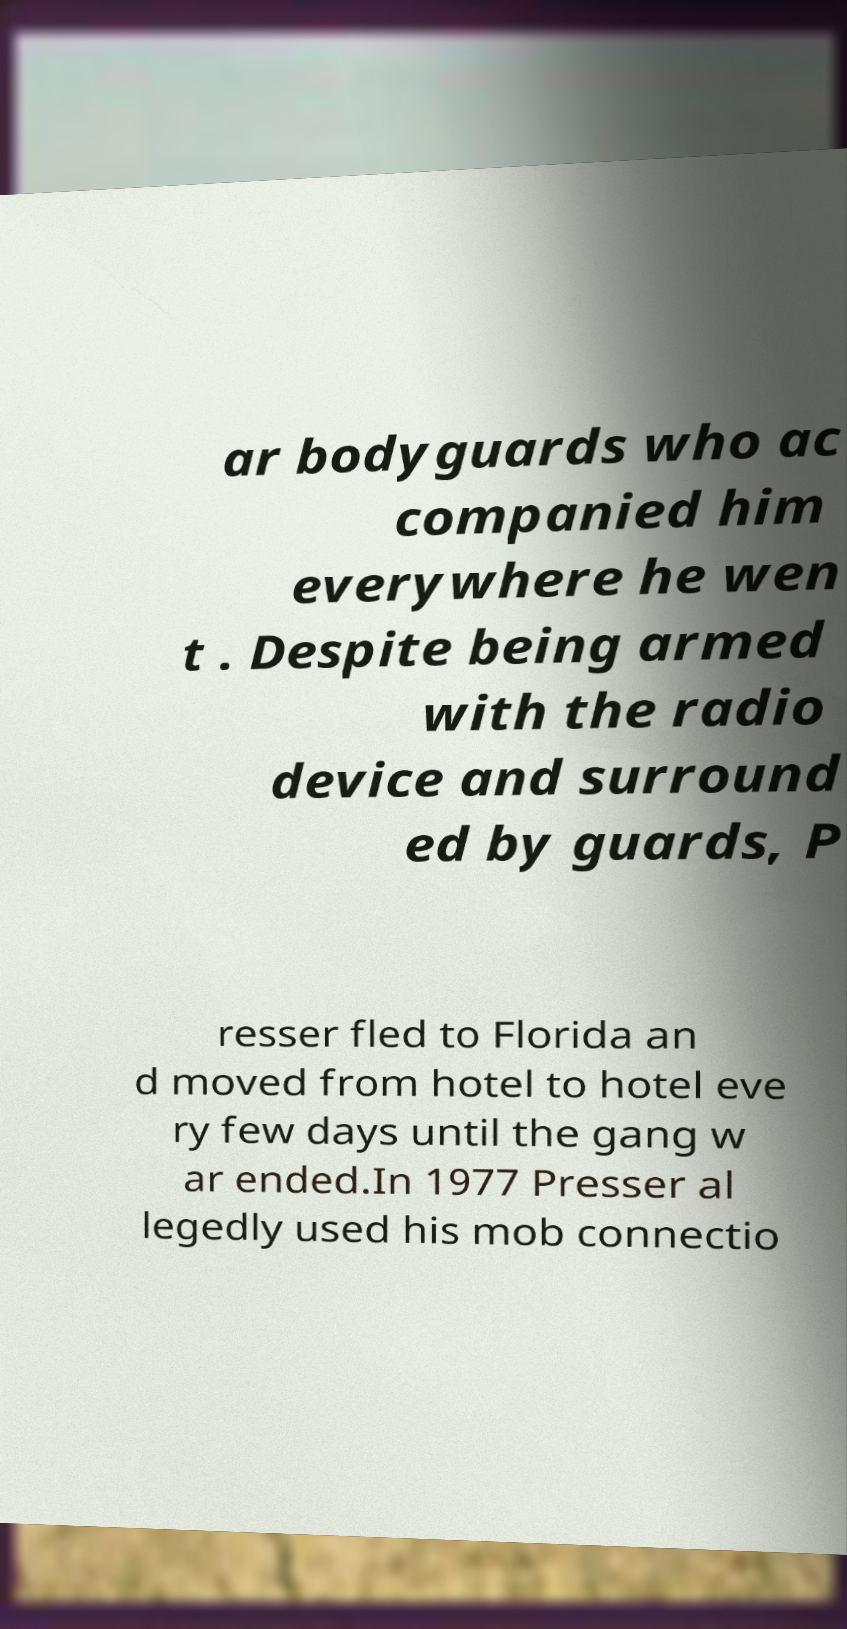Can you read and provide the text displayed in the image?This photo seems to have some interesting text. Can you extract and type it out for me? ar bodyguards who ac companied him everywhere he wen t . Despite being armed with the radio device and surround ed by guards, P resser fled to Florida an d moved from hotel to hotel eve ry few days until the gang w ar ended.In 1977 Presser al legedly used his mob connectio 